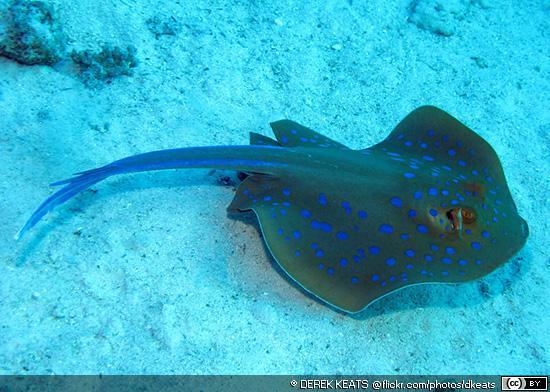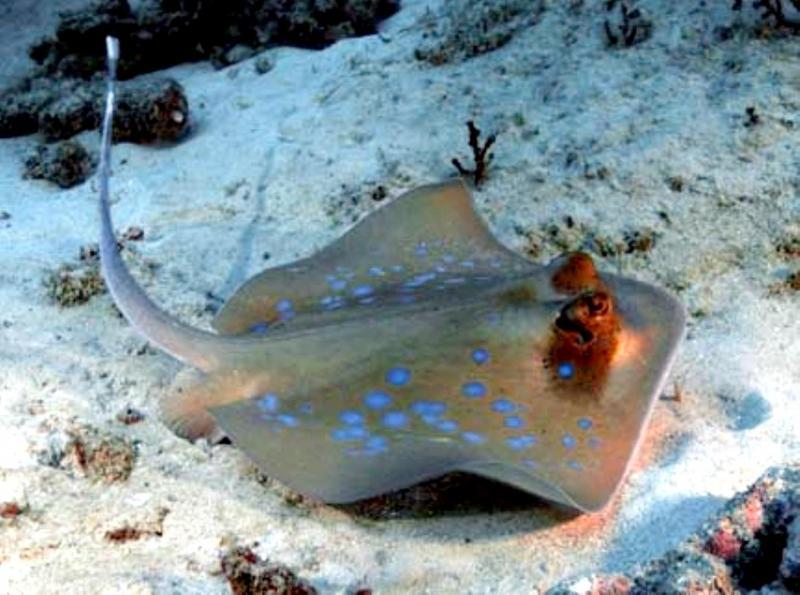The first image is the image on the left, the second image is the image on the right. Given the left and right images, does the statement "The creature in the image on the right is pressed flat against the sea floor." hold true? Answer yes or no. No. 